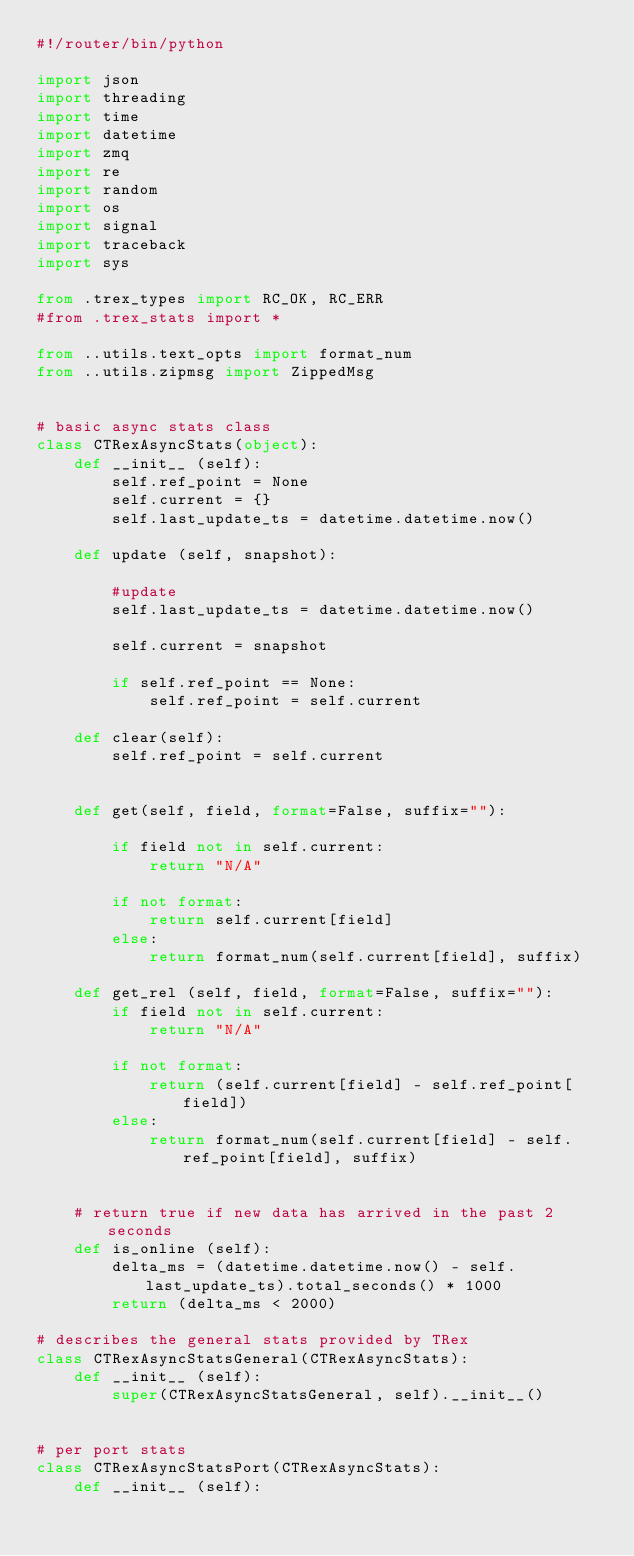Convert code to text. <code><loc_0><loc_0><loc_500><loc_500><_Python_>#!/router/bin/python

import json
import threading
import time
import datetime
import zmq
import re
import random
import os
import signal
import traceback
import sys

from .trex_types import RC_OK, RC_ERR
#from .trex_stats import *

from ..utils.text_opts import format_num
from ..utils.zipmsg import ZippedMsg


# basic async stats class
class CTRexAsyncStats(object):
    def __init__ (self):
        self.ref_point = None
        self.current = {}
        self.last_update_ts = datetime.datetime.now()

    def update (self, snapshot):

        #update
        self.last_update_ts = datetime.datetime.now()

        self.current = snapshot

        if self.ref_point == None:
            self.ref_point = self.current

    def clear(self):
        self.ref_point = self.current
        

    def get(self, field, format=False, suffix=""):

        if field not in self.current:
            return "N/A"

        if not format:
            return self.current[field]
        else:
            return format_num(self.current[field], suffix)

    def get_rel (self, field, format=False, suffix=""):
        if field not in self.current:
            return "N/A"

        if not format:
            return (self.current[field] - self.ref_point[field])
        else:
            return format_num(self.current[field] - self.ref_point[field], suffix)


    # return true if new data has arrived in the past 2 seconds
    def is_online (self):
        delta_ms = (datetime.datetime.now() - self.last_update_ts).total_seconds() * 1000
        return (delta_ms < 2000)

# describes the general stats provided by TRex
class CTRexAsyncStatsGeneral(CTRexAsyncStats):
    def __init__ (self):
        super(CTRexAsyncStatsGeneral, self).__init__()


# per port stats
class CTRexAsyncStatsPort(CTRexAsyncStats):
    def __init__ (self):</code> 